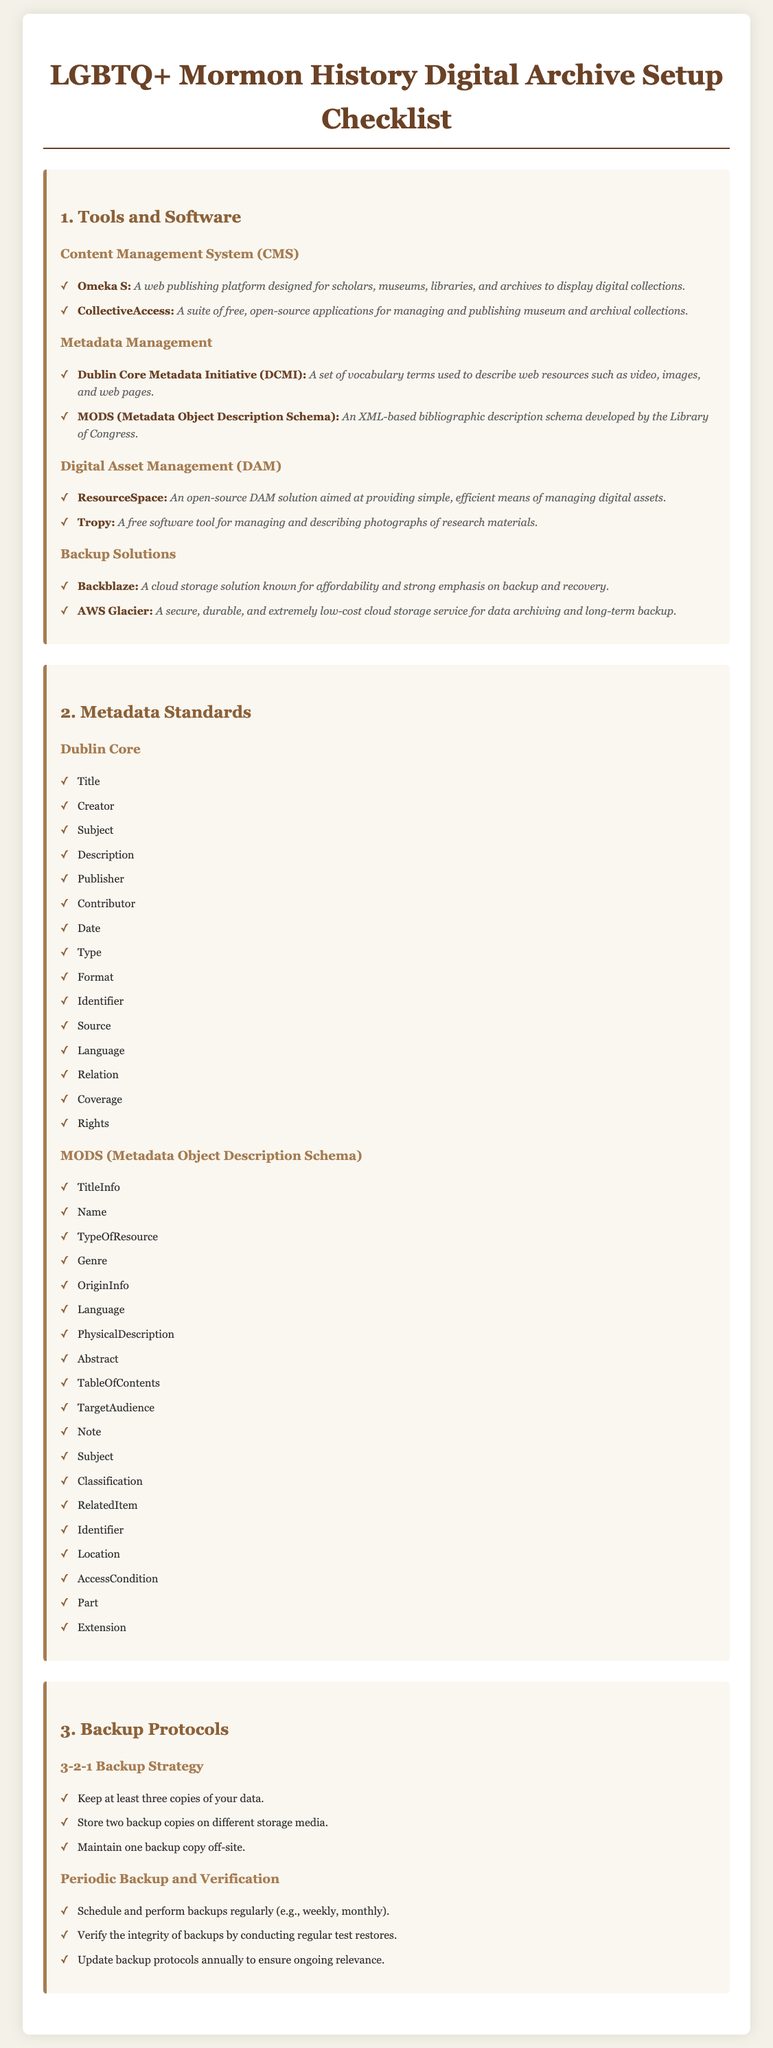What is the title of the checklist? The title of the checklist is presented prominently at the top of the document.
Answer: LGBTQ+ Mormon History Digital Archive Setup Checklist What platform is recommended for a Content Management System? The document lists specific tools under the CMS section, one being a notable platform.
Answer: Omeka S What metadata standard is developed by the Library of Congress? The checklist outlines metadata standards and names a specific XML-based schema associated with the Library of Congress.
Answer: MODS How many copies should be kept in a 3-2-1 backup strategy? The document explains backup protocols and specifies the number of copies to maintain.
Answer: Three What is a recommended tool for managing digital assets? Among the tools listed for digital asset management, a specific open-source solution is mentioned.
Answer: ResourceSpace What is the frequency for scheduling backups according to the document? The document suggests keeping a regular backup schedule, which can be specified as one of several time frames.
Answer: Weekly What is the purpose of using Dublin Core? The document describes the Dublin Core under metadata management, indicating its primary function.
Answer: Describing web resources What should be verified in periodic backup protocols? The document outlines steps to ensure backup effectiveness, highlighting a specific aspect to check regularly.
Answer: Integrity What cloud storage solution is known for affordability? Within the backup solutions, a specific cloud storage service is recognized for its economical aspect.
Answer: Backblaze 